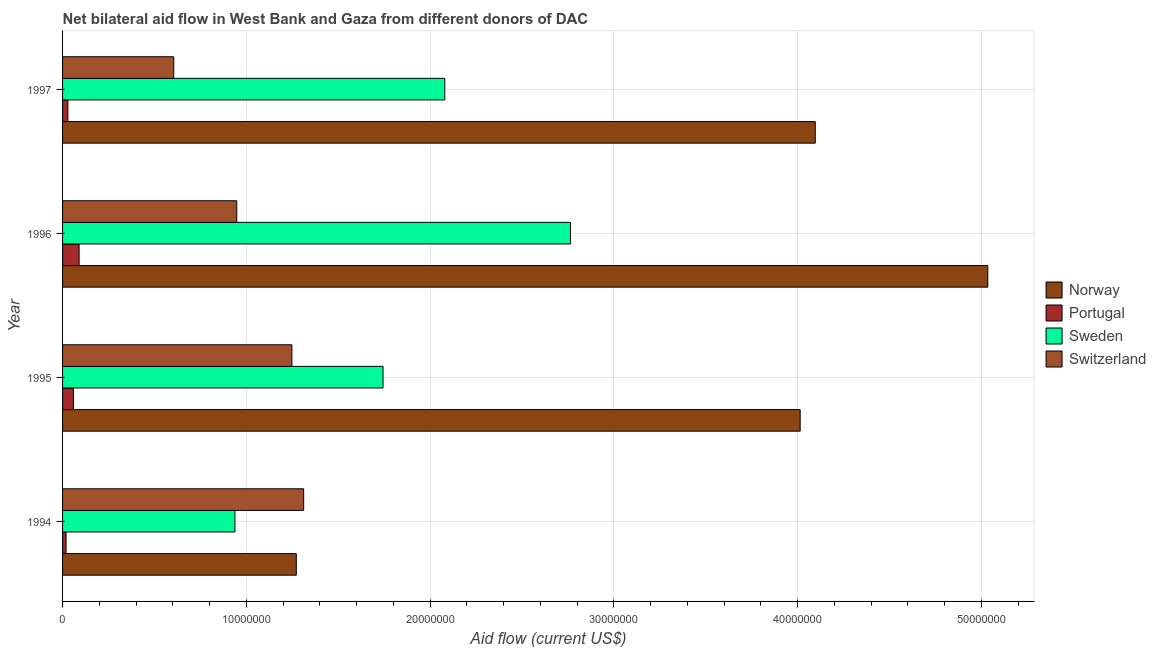Are the number of bars per tick equal to the number of legend labels?
Ensure brevity in your answer.  Yes. Are the number of bars on each tick of the Y-axis equal?
Provide a short and direct response. Yes. What is the label of the 1st group of bars from the top?
Ensure brevity in your answer.  1997. In how many cases, is the number of bars for a given year not equal to the number of legend labels?
Provide a succinct answer. 0. What is the amount of aid given by norway in 1994?
Provide a short and direct response. 1.27e+07. Across all years, what is the maximum amount of aid given by norway?
Your response must be concise. 5.04e+07. Across all years, what is the minimum amount of aid given by switzerland?
Ensure brevity in your answer.  6.05e+06. In which year was the amount of aid given by switzerland maximum?
Your response must be concise. 1994. What is the total amount of aid given by switzerland in the graph?
Provide a succinct answer. 4.11e+07. What is the difference between the amount of aid given by norway in 1994 and that in 1995?
Your answer should be compact. -2.74e+07. What is the difference between the amount of aid given by portugal in 1994 and the amount of aid given by sweden in 1997?
Make the answer very short. -2.06e+07. What is the average amount of aid given by sweden per year?
Keep it short and to the point. 1.88e+07. In the year 1994, what is the difference between the amount of aid given by portugal and amount of aid given by norway?
Make the answer very short. -1.25e+07. What is the ratio of the amount of aid given by sweden in 1996 to that in 1997?
Offer a terse response. 1.33. Is the amount of aid given by portugal in 1995 less than that in 1997?
Ensure brevity in your answer.  No. What is the difference between the highest and the second highest amount of aid given by norway?
Ensure brevity in your answer.  9.39e+06. What is the difference between the highest and the lowest amount of aid given by sweden?
Your answer should be compact. 1.83e+07. What does the 2nd bar from the top in 1996 represents?
Your answer should be very brief. Sweden. What does the 3rd bar from the bottom in 1996 represents?
Offer a very short reply. Sweden. Is it the case that in every year, the sum of the amount of aid given by norway and amount of aid given by portugal is greater than the amount of aid given by sweden?
Keep it short and to the point. Yes. How many bars are there?
Provide a succinct answer. 16. Are all the bars in the graph horizontal?
Make the answer very short. Yes. How many years are there in the graph?
Offer a terse response. 4. What is the difference between two consecutive major ticks on the X-axis?
Provide a short and direct response. 1.00e+07. Does the graph contain any zero values?
Make the answer very short. No. Does the graph contain grids?
Make the answer very short. Yes. How many legend labels are there?
Provide a succinct answer. 4. What is the title of the graph?
Give a very brief answer. Net bilateral aid flow in West Bank and Gaza from different donors of DAC. Does "Payroll services" appear as one of the legend labels in the graph?
Make the answer very short. No. What is the label or title of the X-axis?
Give a very brief answer. Aid flow (current US$). What is the Aid flow (current US$) of Norway in 1994?
Keep it short and to the point. 1.27e+07. What is the Aid flow (current US$) in Sweden in 1994?
Provide a short and direct response. 9.38e+06. What is the Aid flow (current US$) in Switzerland in 1994?
Your response must be concise. 1.31e+07. What is the Aid flow (current US$) of Norway in 1995?
Ensure brevity in your answer.  4.01e+07. What is the Aid flow (current US$) of Portugal in 1995?
Provide a succinct answer. 5.90e+05. What is the Aid flow (current US$) of Sweden in 1995?
Make the answer very short. 1.74e+07. What is the Aid flow (current US$) in Switzerland in 1995?
Provide a succinct answer. 1.25e+07. What is the Aid flow (current US$) in Norway in 1996?
Provide a succinct answer. 5.04e+07. What is the Aid flow (current US$) of Sweden in 1996?
Offer a terse response. 2.76e+07. What is the Aid flow (current US$) in Switzerland in 1996?
Ensure brevity in your answer.  9.48e+06. What is the Aid flow (current US$) of Norway in 1997?
Ensure brevity in your answer.  4.10e+07. What is the Aid flow (current US$) of Sweden in 1997?
Offer a terse response. 2.08e+07. What is the Aid flow (current US$) in Switzerland in 1997?
Make the answer very short. 6.05e+06. Across all years, what is the maximum Aid flow (current US$) in Norway?
Ensure brevity in your answer.  5.04e+07. Across all years, what is the maximum Aid flow (current US$) in Portugal?
Your answer should be very brief. 9.00e+05. Across all years, what is the maximum Aid flow (current US$) of Sweden?
Keep it short and to the point. 2.76e+07. Across all years, what is the maximum Aid flow (current US$) in Switzerland?
Offer a very short reply. 1.31e+07. Across all years, what is the minimum Aid flow (current US$) of Norway?
Your response must be concise. 1.27e+07. Across all years, what is the minimum Aid flow (current US$) of Sweden?
Offer a very short reply. 9.38e+06. Across all years, what is the minimum Aid flow (current US$) in Switzerland?
Provide a short and direct response. 6.05e+06. What is the total Aid flow (current US$) in Norway in the graph?
Provide a succinct answer. 1.44e+08. What is the total Aid flow (current US$) of Portugal in the graph?
Make the answer very short. 1.97e+06. What is the total Aid flow (current US$) of Sweden in the graph?
Provide a succinct answer. 7.53e+07. What is the total Aid flow (current US$) in Switzerland in the graph?
Your response must be concise. 4.11e+07. What is the difference between the Aid flow (current US$) in Norway in 1994 and that in 1995?
Offer a terse response. -2.74e+07. What is the difference between the Aid flow (current US$) of Portugal in 1994 and that in 1995?
Make the answer very short. -4.00e+05. What is the difference between the Aid flow (current US$) in Sweden in 1994 and that in 1995?
Offer a terse response. -8.06e+06. What is the difference between the Aid flow (current US$) in Switzerland in 1994 and that in 1995?
Ensure brevity in your answer.  6.40e+05. What is the difference between the Aid flow (current US$) of Norway in 1994 and that in 1996?
Your answer should be compact. -3.76e+07. What is the difference between the Aid flow (current US$) of Portugal in 1994 and that in 1996?
Provide a short and direct response. -7.10e+05. What is the difference between the Aid flow (current US$) of Sweden in 1994 and that in 1996?
Give a very brief answer. -1.83e+07. What is the difference between the Aid flow (current US$) in Switzerland in 1994 and that in 1996?
Offer a terse response. 3.64e+06. What is the difference between the Aid flow (current US$) of Norway in 1994 and that in 1997?
Your answer should be compact. -2.82e+07. What is the difference between the Aid flow (current US$) of Portugal in 1994 and that in 1997?
Offer a terse response. -1.00e+05. What is the difference between the Aid flow (current US$) of Sweden in 1994 and that in 1997?
Provide a short and direct response. -1.14e+07. What is the difference between the Aid flow (current US$) in Switzerland in 1994 and that in 1997?
Your answer should be compact. 7.07e+06. What is the difference between the Aid flow (current US$) in Norway in 1995 and that in 1996?
Your response must be concise. -1.02e+07. What is the difference between the Aid flow (current US$) in Portugal in 1995 and that in 1996?
Ensure brevity in your answer.  -3.10e+05. What is the difference between the Aid flow (current US$) of Sweden in 1995 and that in 1996?
Your response must be concise. -1.02e+07. What is the difference between the Aid flow (current US$) of Switzerland in 1995 and that in 1996?
Make the answer very short. 3.00e+06. What is the difference between the Aid flow (current US$) in Norway in 1995 and that in 1997?
Make the answer very short. -8.20e+05. What is the difference between the Aid flow (current US$) of Sweden in 1995 and that in 1997?
Your answer should be compact. -3.36e+06. What is the difference between the Aid flow (current US$) of Switzerland in 1995 and that in 1997?
Give a very brief answer. 6.43e+06. What is the difference between the Aid flow (current US$) in Norway in 1996 and that in 1997?
Ensure brevity in your answer.  9.39e+06. What is the difference between the Aid flow (current US$) in Portugal in 1996 and that in 1997?
Your answer should be compact. 6.10e+05. What is the difference between the Aid flow (current US$) of Sweden in 1996 and that in 1997?
Make the answer very short. 6.84e+06. What is the difference between the Aid flow (current US$) in Switzerland in 1996 and that in 1997?
Keep it short and to the point. 3.43e+06. What is the difference between the Aid flow (current US$) in Norway in 1994 and the Aid flow (current US$) in Portugal in 1995?
Offer a very short reply. 1.21e+07. What is the difference between the Aid flow (current US$) of Norway in 1994 and the Aid flow (current US$) of Sweden in 1995?
Provide a short and direct response. -4.72e+06. What is the difference between the Aid flow (current US$) in Portugal in 1994 and the Aid flow (current US$) in Sweden in 1995?
Offer a very short reply. -1.72e+07. What is the difference between the Aid flow (current US$) of Portugal in 1994 and the Aid flow (current US$) of Switzerland in 1995?
Your response must be concise. -1.23e+07. What is the difference between the Aid flow (current US$) of Sweden in 1994 and the Aid flow (current US$) of Switzerland in 1995?
Make the answer very short. -3.10e+06. What is the difference between the Aid flow (current US$) in Norway in 1994 and the Aid flow (current US$) in Portugal in 1996?
Your answer should be very brief. 1.18e+07. What is the difference between the Aid flow (current US$) of Norway in 1994 and the Aid flow (current US$) of Sweden in 1996?
Keep it short and to the point. -1.49e+07. What is the difference between the Aid flow (current US$) in Norway in 1994 and the Aid flow (current US$) in Switzerland in 1996?
Your answer should be compact. 3.24e+06. What is the difference between the Aid flow (current US$) of Portugal in 1994 and the Aid flow (current US$) of Sweden in 1996?
Offer a very short reply. -2.74e+07. What is the difference between the Aid flow (current US$) in Portugal in 1994 and the Aid flow (current US$) in Switzerland in 1996?
Ensure brevity in your answer.  -9.29e+06. What is the difference between the Aid flow (current US$) of Sweden in 1994 and the Aid flow (current US$) of Switzerland in 1996?
Your response must be concise. -1.00e+05. What is the difference between the Aid flow (current US$) of Norway in 1994 and the Aid flow (current US$) of Portugal in 1997?
Ensure brevity in your answer.  1.24e+07. What is the difference between the Aid flow (current US$) in Norway in 1994 and the Aid flow (current US$) in Sweden in 1997?
Ensure brevity in your answer.  -8.08e+06. What is the difference between the Aid flow (current US$) of Norway in 1994 and the Aid flow (current US$) of Switzerland in 1997?
Offer a terse response. 6.67e+06. What is the difference between the Aid flow (current US$) in Portugal in 1994 and the Aid flow (current US$) in Sweden in 1997?
Your answer should be compact. -2.06e+07. What is the difference between the Aid flow (current US$) in Portugal in 1994 and the Aid flow (current US$) in Switzerland in 1997?
Provide a short and direct response. -5.86e+06. What is the difference between the Aid flow (current US$) in Sweden in 1994 and the Aid flow (current US$) in Switzerland in 1997?
Give a very brief answer. 3.33e+06. What is the difference between the Aid flow (current US$) in Norway in 1995 and the Aid flow (current US$) in Portugal in 1996?
Provide a short and direct response. 3.92e+07. What is the difference between the Aid flow (current US$) of Norway in 1995 and the Aid flow (current US$) of Sweden in 1996?
Make the answer very short. 1.25e+07. What is the difference between the Aid flow (current US$) in Norway in 1995 and the Aid flow (current US$) in Switzerland in 1996?
Your response must be concise. 3.07e+07. What is the difference between the Aid flow (current US$) in Portugal in 1995 and the Aid flow (current US$) in Sweden in 1996?
Your response must be concise. -2.70e+07. What is the difference between the Aid flow (current US$) of Portugal in 1995 and the Aid flow (current US$) of Switzerland in 1996?
Give a very brief answer. -8.89e+06. What is the difference between the Aid flow (current US$) of Sweden in 1995 and the Aid flow (current US$) of Switzerland in 1996?
Give a very brief answer. 7.96e+06. What is the difference between the Aid flow (current US$) of Norway in 1995 and the Aid flow (current US$) of Portugal in 1997?
Provide a short and direct response. 3.98e+07. What is the difference between the Aid flow (current US$) in Norway in 1995 and the Aid flow (current US$) in Sweden in 1997?
Make the answer very short. 1.93e+07. What is the difference between the Aid flow (current US$) of Norway in 1995 and the Aid flow (current US$) of Switzerland in 1997?
Keep it short and to the point. 3.41e+07. What is the difference between the Aid flow (current US$) of Portugal in 1995 and the Aid flow (current US$) of Sweden in 1997?
Make the answer very short. -2.02e+07. What is the difference between the Aid flow (current US$) of Portugal in 1995 and the Aid flow (current US$) of Switzerland in 1997?
Keep it short and to the point. -5.46e+06. What is the difference between the Aid flow (current US$) in Sweden in 1995 and the Aid flow (current US$) in Switzerland in 1997?
Make the answer very short. 1.14e+07. What is the difference between the Aid flow (current US$) in Norway in 1996 and the Aid flow (current US$) in Portugal in 1997?
Make the answer very short. 5.01e+07. What is the difference between the Aid flow (current US$) in Norway in 1996 and the Aid flow (current US$) in Sweden in 1997?
Make the answer very short. 2.96e+07. What is the difference between the Aid flow (current US$) in Norway in 1996 and the Aid flow (current US$) in Switzerland in 1997?
Your answer should be very brief. 4.43e+07. What is the difference between the Aid flow (current US$) of Portugal in 1996 and the Aid flow (current US$) of Sweden in 1997?
Ensure brevity in your answer.  -1.99e+07. What is the difference between the Aid flow (current US$) in Portugal in 1996 and the Aid flow (current US$) in Switzerland in 1997?
Provide a short and direct response. -5.15e+06. What is the difference between the Aid flow (current US$) in Sweden in 1996 and the Aid flow (current US$) in Switzerland in 1997?
Ensure brevity in your answer.  2.16e+07. What is the average Aid flow (current US$) of Norway per year?
Your answer should be very brief. 3.60e+07. What is the average Aid flow (current US$) in Portugal per year?
Offer a terse response. 4.92e+05. What is the average Aid flow (current US$) in Sweden per year?
Ensure brevity in your answer.  1.88e+07. What is the average Aid flow (current US$) of Switzerland per year?
Make the answer very short. 1.03e+07. In the year 1994, what is the difference between the Aid flow (current US$) in Norway and Aid flow (current US$) in Portugal?
Offer a very short reply. 1.25e+07. In the year 1994, what is the difference between the Aid flow (current US$) in Norway and Aid flow (current US$) in Sweden?
Make the answer very short. 3.34e+06. In the year 1994, what is the difference between the Aid flow (current US$) of Norway and Aid flow (current US$) of Switzerland?
Make the answer very short. -4.00e+05. In the year 1994, what is the difference between the Aid flow (current US$) in Portugal and Aid flow (current US$) in Sweden?
Your response must be concise. -9.19e+06. In the year 1994, what is the difference between the Aid flow (current US$) in Portugal and Aid flow (current US$) in Switzerland?
Make the answer very short. -1.29e+07. In the year 1994, what is the difference between the Aid flow (current US$) of Sweden and Aid flow (current US$) of Switzerland?
Offer a very short reply. -3.74e+06. In the year 1995, what is the difference between the Aid flow (current US$) of Norway and Aid flow (current US$) of Portugal?
Your response must be concise. 3.96e+07. In the year 1995, what is the difference between the Aid flow (current US$) in Norway and Aid flow (current US$) in Sweden?
Offer a very short reply. 2.27e+07. In the year 1995, what is the difference between the Aid flow (current US$) in Norway and Aid flow (current US$) in Switzerland?
Provide a succinct answer. 2.77e+07. In the year 1995, what is the difference between the Aid flow (current US$) of Portugal and Aid flow (current US$) of Sweden?
Keep it short and to the point. -1.68e+07. In the year 1995, what is the difference between the Aid flow (current US$) of Portugal and Aid flow (current US$) of Switzerland?
Give a very brief answer. -1.19e+07. In the year 1995, what is the difference between the Aid flow (current US$) in Sweden and Aid flow (current US$) in Switzerland?
Provide a short and direct response. 4.96e+06. In the year 1996, what is the difference between the Aid flow (current US$) in Norway and Aid flow (current US$) in Portugal?
Your response must be concise. 4.94e+07. In the year 1996, what is the difference between the Aid flow (current US$) of Norway and Aid flow (current US$) of Sweden?
Offer a very short reply. 2.27e+07. In the year 1996, what is the difference between the Aid flow (current US$) in Norway and Aid flow (current US$) in Switzerland?
Ensure brevity in your answer.  4.09e+07. In the year 1996, what is the difference between the Aid flow (current US$) of Portugal and Aid flow (current US$) of Sweden?
Provide a short and direct response. -2.67e+07. In the year 1996, what is the difference between the Aid flow (current US$) of Portugal and Aid flow (current US$) of Switzerland?
Keep it short and to the point. -8.58e+06. In the year 1996, what is the difference between the Aid flow (current US$) in Sweden and Aid flow (current US$) in Switzerland?
Your answer should be very brief. 1.82e+07. In the year 1997, what is the difference between the Aid flow (current US$) in Norway and Aid flow (current US$) in Portugal?
Provide a succinct answer. 4.07e+07. In the year 1997, what is the difference between the Aid flow (current US$) in Norway and Aid flow (current US$) in Sweden?
Give a very brief answer. 2.02e+07. In the year 1997, what is the difference between the Aid flow (current US$) in Norway and Aid flow (current US$) in Switzerland?
Keep it short and to the point. 3.49e+07. In the year 1997, what is the difference between the Aid flow (current US$) in Portugal and Aid flow (current US$) in Sweden?
Offer a terse response. -2.05e+07. In the year 1997, what is the difference between the Aid flow (current US$) in Portugal and Aid flow (current US$) in Switzerland?
Give a very brief answer. -5.76e+06. In the year 1997, what is the difference between the Aid flow (current US$) in Sweden and Aid flow (current US$) in Switzerland?
Offer a very short reply. 1.48e+07. What is the ratio of the Aid flow (current US$) of Norway in 1994 to that in 1995?
Make the answer very short. 0.32. What is the ratio of the Aid flow (current US$) of Portugal in 1994 to that in 1995?
Ensure brevity in your answer.  0.32. What is the ratio of the Aid flow (current US$) in Sweden in 1994 to that in 1995?
Provide a succinct answer. 0.54. What is the ratio of the Aid flow (current US$) of Switzerland in 1994 to that in 1995?
Your answer should be very brief. 1.05. What is the ratio of the Aid flow (current US$) of Norway in 1994 to that in 1996?
Keep it short and to the point. 0.25. What is the ratio of the Aid flow (current US$) of Portugal in 1994 to that in 1996?
Offer a very short reply. 0.21. What is the ratio of the Aid flow (current US$) of Sweden in 1994 to that in 1996?
Provide a short and direct response. 0.34. What is the ratio of the Aid flow (current US$) of Switzerland in 1994 to that in 1996?
Ensure brevity in your answer.  1.38. What is the ratio of the Aid flow (current US$) in Norway in 1994 to that in 1997?
Keep it short and to the point. 0.31. What is the ratio of the Aid flow (current US$) in Portugal in 1994 to that in 1997?
Provide a short and direct response. 0.66. What is the ratio of the Aid flow (current US$) in Sweden in 1994 to that in 1997?
Offer a very short reply. 0.45. What is the ratio of the Aid flow (current US$) of Switzerland in 1994 to that in 1997?
Provide a succinct answer. 2.17. What is the ratio of the Aid flow (current US$) of Norway in 1995 to that in 1996?
Keep it short and to the point. 0.8. What is the ratio of the Aid flow (current US$) of Portugal in 1995 to that in 1996?
Provide a succinct answer. 0.66. What is the ratio of the Aid flow (current US$) of Sweden in 1995 to that in 1996?
Give a very brief answer. 0.63. What is the ratio of the Aid flow (current US$) of Switzerland in 1995 to that in 1996?
Provide a short and direct response. 1.32. What is the ratio of the Aid flow (current US$) of Norway in 1995 to that in 1997?
Offer a very short reply. 0.98. What is the ratio of the Aid flow (current US$) in Portugal in 1995 to that in 1997?
Keep it short and to the point. 2.03. What is the ratio of the Aid flow (current US$) of Sweden in 1995 to that in 1997?
Offer a terse response. 0.84. What is the ratio of the Aid flow (current US$) of Switzerland in 1995 to that in 1997?
Provide a succinct answer. 2.06. What is the ratio of the Aid flow (current US$) in Norway in 1996 to that in 1997?
Make the answer very short. 1.23. What is the ratio of the Aid flow (current US$) in Portugal in 1996 to that in 1997?
Your answer should be very brief. 3.1. What is the ratio of the Aid flow (current US$) in Sweden in 1996 to that in 1997?
Offer a very short reply. 1.33. What is the ratio of the Aid flow (current US$) in Switzerland in 1996 to that in 1997?
Offer a terse response. 1.57. What is the difference between the highest and the second highest Aid flow (current US$) in Norway?
Your answer should be very brief. 9.39e+06. What is the difference between the highest and the second highest Aid flow (current US$) in Sweden?
Your answer should be compact. 6.84e+06. What is the difference between the highest and the second highest Aid flow (current US$) of Switzerland?
Offer a very short reply. 6.40e+05. What is the difference between the highest and the lowest Aid flow (current US$) in Norway?
Offer a terse response. 3.76e+07. What is the difference between the highest and the lowest Aid flow (current US$) in Portugal?
Keep it short and to the point. 7.10e+05. What is the difference between the highest and the lowest Aid flow (current US$) of Sweden?
Offer a very short reply. 1.83e+07. What is the difference between the highest and the lowest Aid flow (current US$) in Switzerland?
Ensure brevity in your answer.  7.07e+06. 